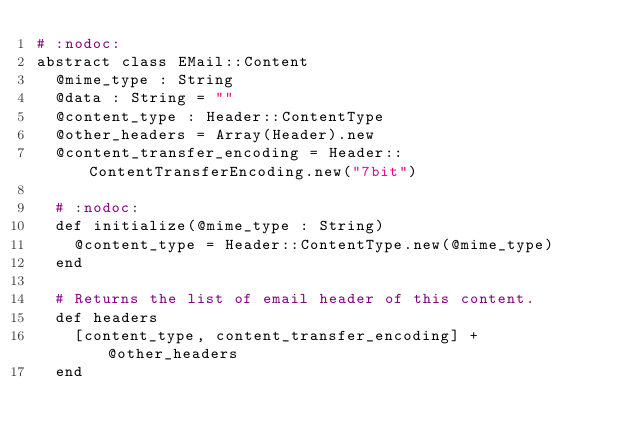<code> <loc_0><loc_0><loc_500><loc_500><_Crystal_># :nodoc:
abstract class EMail::Content
  @mime_type : String
  @data : String = ""
  @content_type : Header::ContentType
  @other_headers = Array(Header).new
  @content_transfer_encoding = Header::ContentTransferEncoding.new("7bit")

  # :nodoc:
  def initialize(@mime_type : String)
    @content_type = Header::ContentType.new(@mime_type)
  end

  # Returns the list of email header of this content.
  def headers
    [content_type, content_transfer_encoding] + @other_headers
  end
</code> 